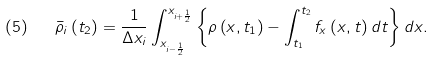Convert formula to latex. <formula><loc_0><loc_0><loc_500><loc_500>( 5 ) \quad { \bar { \rho } } _ { i } \left ( t _ { 2 } \right ) = { \frac { 1 } { \Delta x _ { i } } } \int _ { x _ { i - { \frac { 1 } { 2 } } } } ^ { x _ { i + { \frac { 1 } { 2 } } } } \left \{ \rho \left ( x , t _ { 1 } \right ) - \int _ { t _ { 1 } } ^ { t _ { 2 } } f _ { x } \left ( x , t \right ) d t \right \} d x .</formula> 